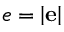Convert formula to latex. <formula><loc_0><loc_0><loc_500><loc_500>e = \left | e \right |</formula> 